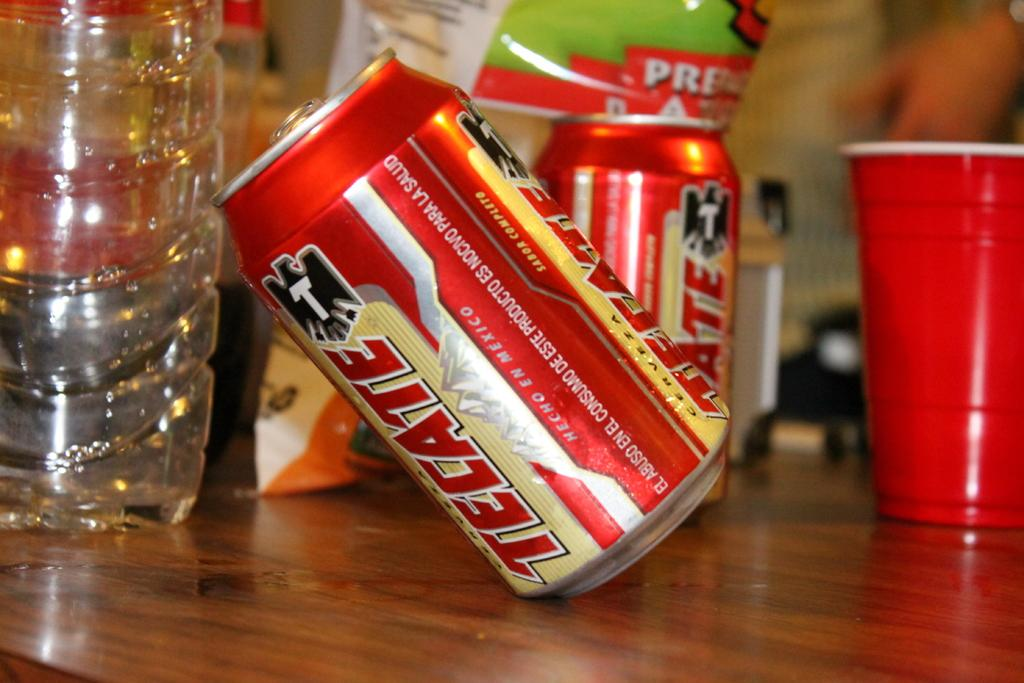Provide a one-sentence caption for the provided image. Two cans of Tecate beer and a red cup are on a wooden table. 